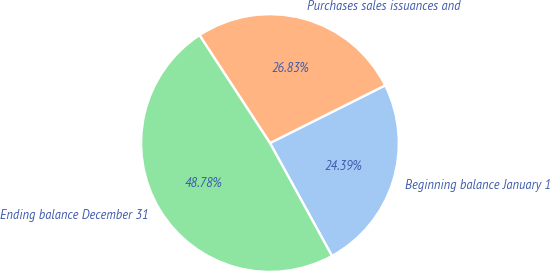Convert chart. <chart><loc_0><loc_0><loc_500><loc_500><pie_chart><fcel>Beginning balance January 1<fcel>Purchases sales issuances and<fcel>Ending balance December 31<nl><fcel>24.39%<fcel>26.83%<fcel>48.78%<nl></chart> 